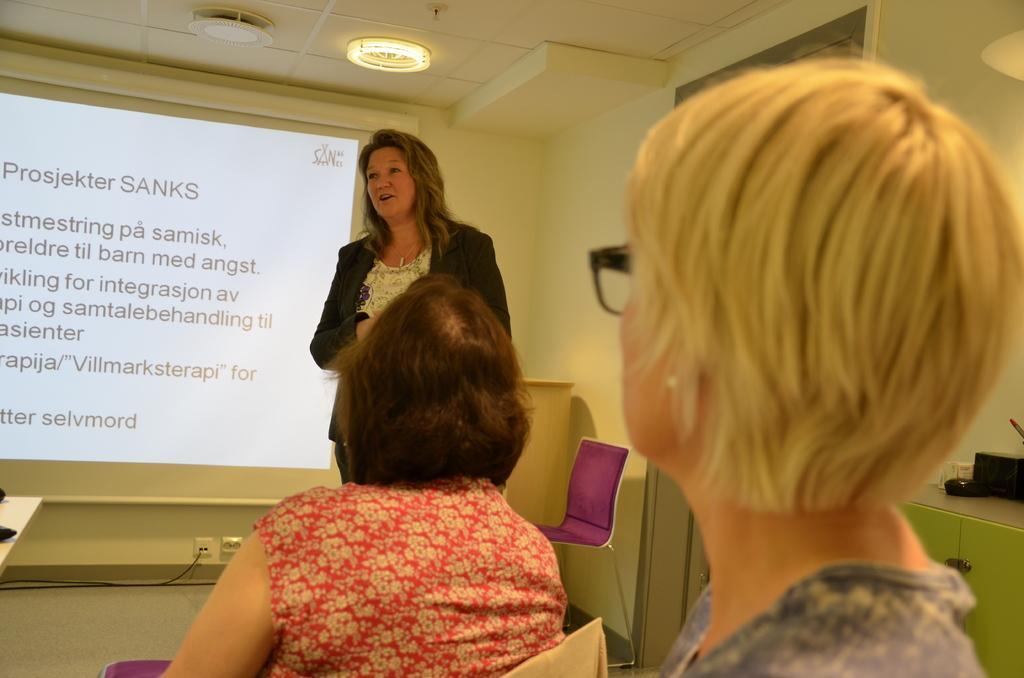In one or two sentences, can you explain what this image depicts? In this image there is a person speaking in front of the people, there is a screen with some text, chairs, some objects on the desk and lights attached to the ceiling. 